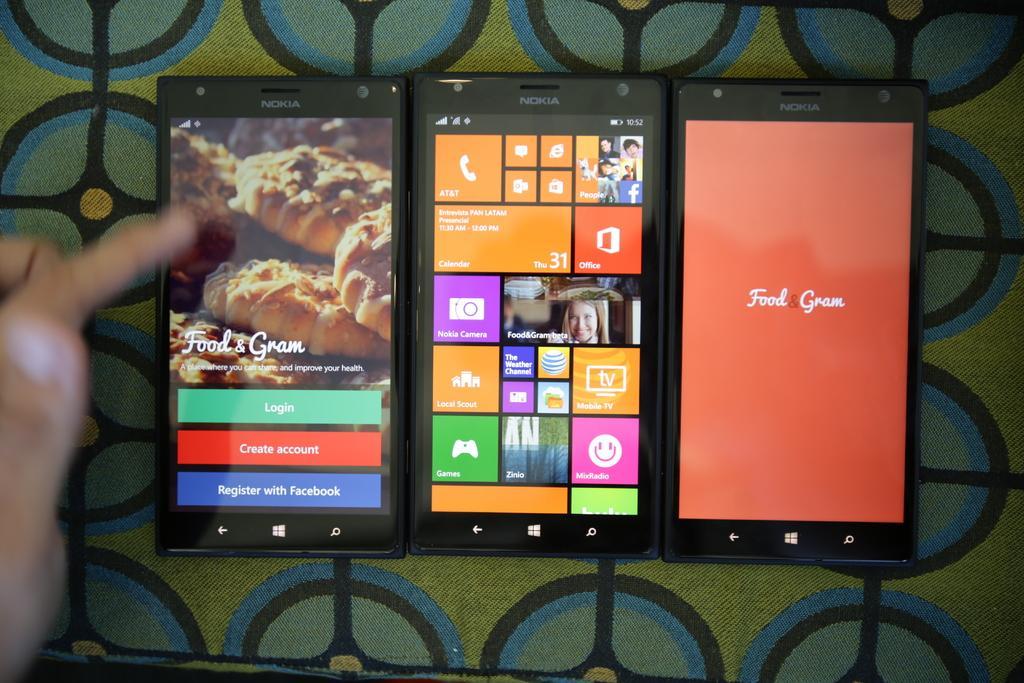In one or two sentences, can you explain what this image depicts? In the center of the picture there are three mobiles on a surface. On the left there is a person's hand. 